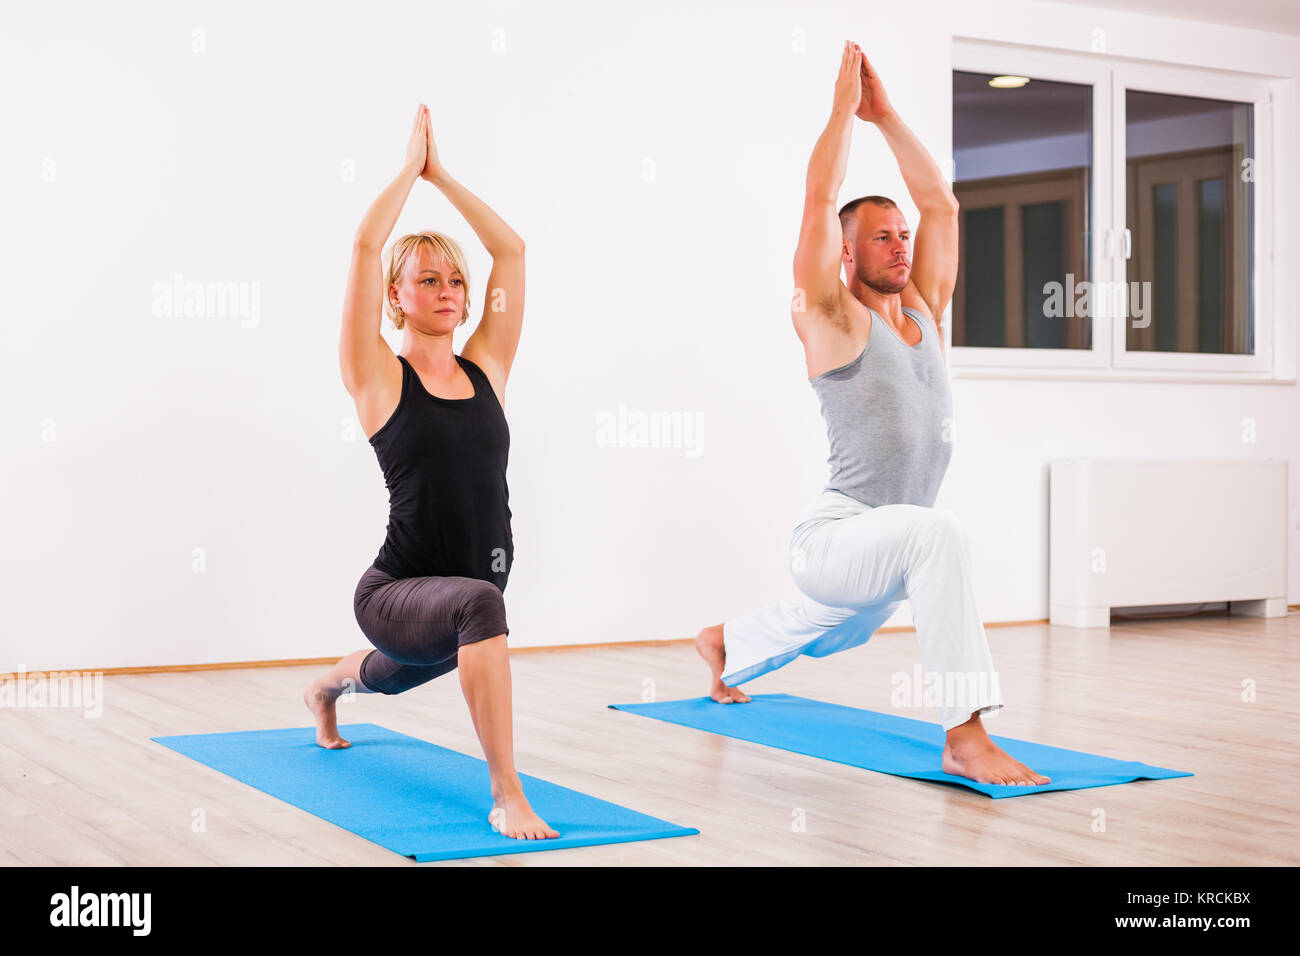What is the name of the yoga pose? The yoga pose being performed by both individuals is commonly known as the "Anjaneyasana" or "Crescent Lunge." It is a standing pose that stretches the thighs, groin, and hip flexors, while also expanding the chest, lungs, and shoulders. It helps in developing balance and concentration. The precise alignment of the arms above the head with the palms touching brings an additional element of balance and centering to the pose. This posture is often included in yoga sequences to build lower body strength and flexibility. 